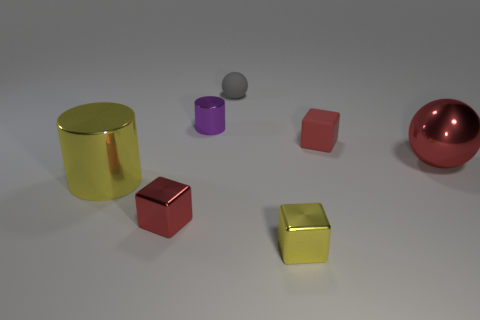There is a red cube that is made of the same material as the small purple cylinder; what is its size?
Offer a terse response. Small. What number of things are red things in front of the large red metallic ball or large green metallic balls?
Offer a very short reply. 1. There is a tiny block that is to the left of the small purple object; does it have the same color as the big metal ball?
Offer a very short reply. Yes. There is a red rubber object that is the same shape as the tiny yellow metal thing; what size is it?
Make the answer very short. Small. There is a metal object that is right of the yellow metal object in front of the shiny block that is behind the tiny yellow shiny object; what is its color?
Provide a short and direct response. Red. Is the tiny yellow cube made of the same material as the gray thing?
Give a very brief answer. No. There is a metal cylinder to the right of the cylinder in front of the big red object; are there any red blocks that are left of it?
Provide a short and direct response. Yes. Do the metal sphere and the rubber block have the same color?
Make the answer very short. Yes. Are there fewer gray objects than tiny brown shiny cylinders?
Provide a short and direct response. No. Are the large red ball in front of the matte sphere and the cylinder left of the purple object made of the same material?
Give a very brief answer. Yes. 